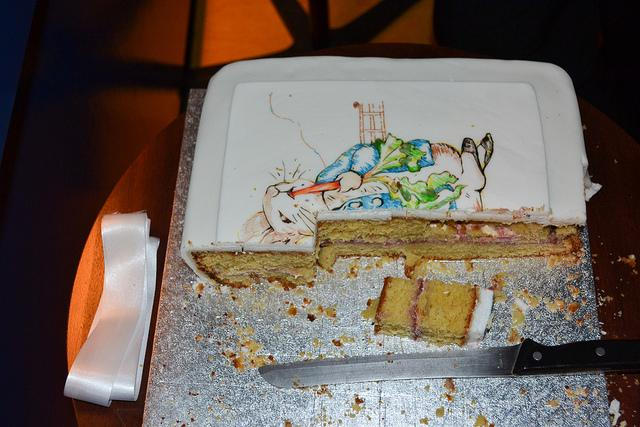Which age range may this cake have been for?

Choices:
A) child
B) grandparent
C) teenager
D) young adult child 